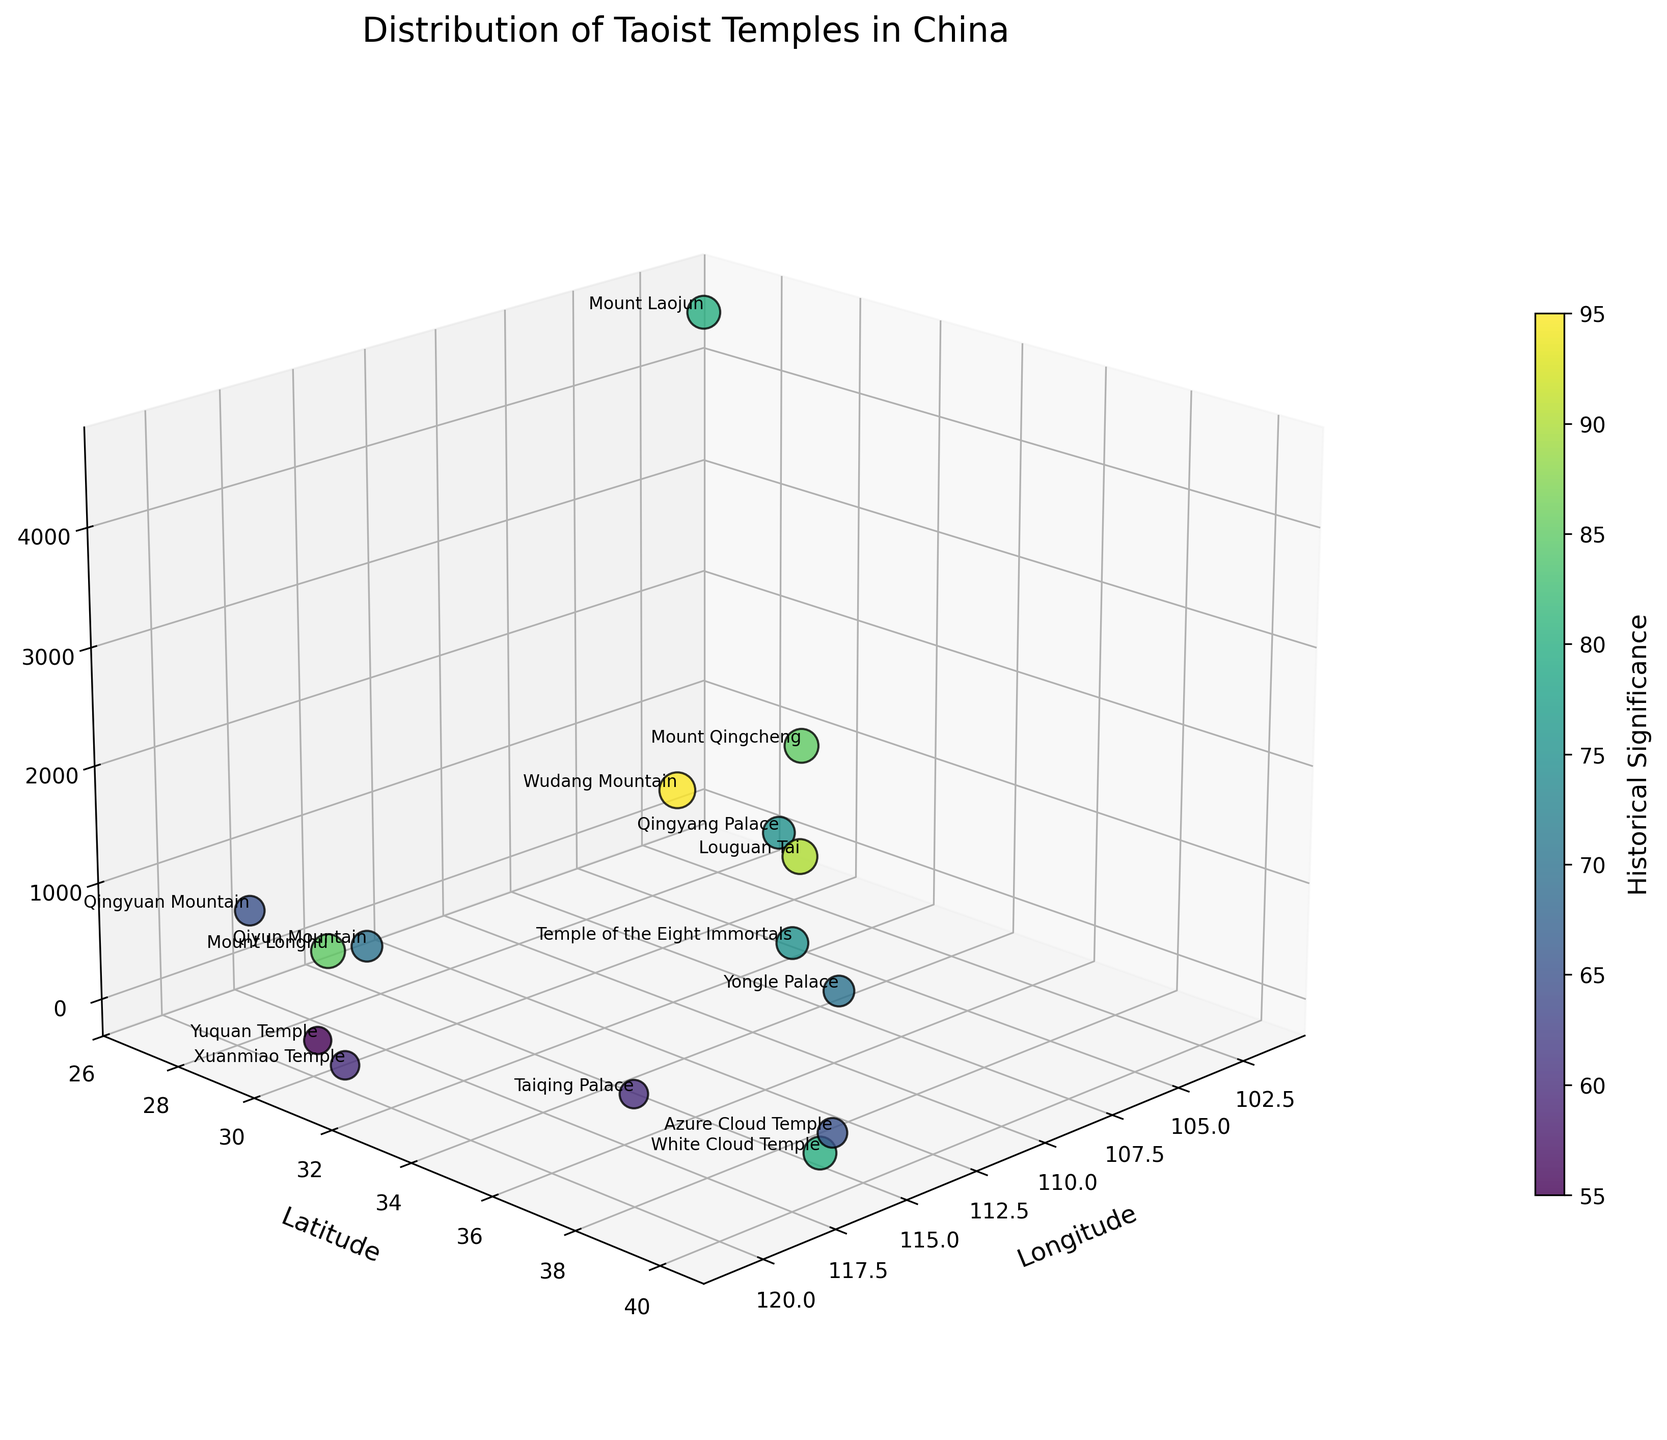How many Taoist temples are depicted in the figure? To find the number of Taoist temples, we count the distinct data points represented by the scatter points in the 3D plot. Each point corresponds to one temple. In the data set, there are 15 temples listed.
Answer: 15 Which temple is situated at the highest elevation? In the 3D scatter plot, look for the point with the greatest value on the Elevation axis. According to the data, Mount Laojun, with an elevation of 4500 meters, has the highest elevation among the plotted temples.
Answer: Mount Laojun What is the title of the figure? The title is typically displayed at the top of the figure. For this plot, it is specified in the code as 'Distribution of Taoist Temples in China'.
Answer: Distribution of Taoist Temples in China Which temple has the lowest historical significance? In the scatter plot, the points' colors and sizes indicate historical significance. The lower the value, the smaller and lighter the point. According to the data, Yuquan Temple has the lowest historical significance with a value of 55.
Answer: Yuquan Temple How do Longitude and Latitude axes contribute to identifying the location of a temple? Longitude represents the horizontal position (X-axis), and Latitude represents the vertical position (Y-axis) on the map. Each temple's location is therefore uniquely determined by its Longitude and Latitude coordinates on the 3D plot.
Answer: By showing horizontal (longitude) and vertical (latitude) positions What is the average elevation of all listed temples? Sum the elevations of all temples and divide by the number of temples: (1612 + 44 + 1260 + 585 + 1200 + 220 + 400 + 152 + 42 + 4500 + 710 + 750 + 10 + 247 + 500) / 15 = 11532 / 15 = 768.8
Answer: 768.8 meters Which two temples are closest to each other in terms of location (Longitude and Latitude)? By examining the scatter plot, we identify the two data points that are nearest to each other in the Longitude-Latitude plane. Based on the data, Azure Cloud Temple and White Cloud Temple both have longitudes around 116 and latitudes around 40, and appear close in the plot.
Answer: Azure Cloud Temple and White Cloud Temple What is the historical significance of Wudang Mountain compared to Mount Qingcheng? From the plot, check the color and size of the points representing Wudang Mountain and Mount Qingcheng. Wudang Mountain's historical significance is 95, while Mount Qingcheng's is 85.
Answer: Wudang Mountain has higher historical significance Why might some temples appear larger in size on the plot? Larger points on the scatter plot indicate greater historical significance. The size of each point is proportional to its historical significance value, so temples with high historical significance appear larger.
Answer: Higher historical significance Which temple is labeled with the highest historical significance? Examining the plot for the largest and darkest shaded point with a label can identify this. Wudang Mountain, with a historical significance of 95, is the highest.
Answer: Wudang Mountain 